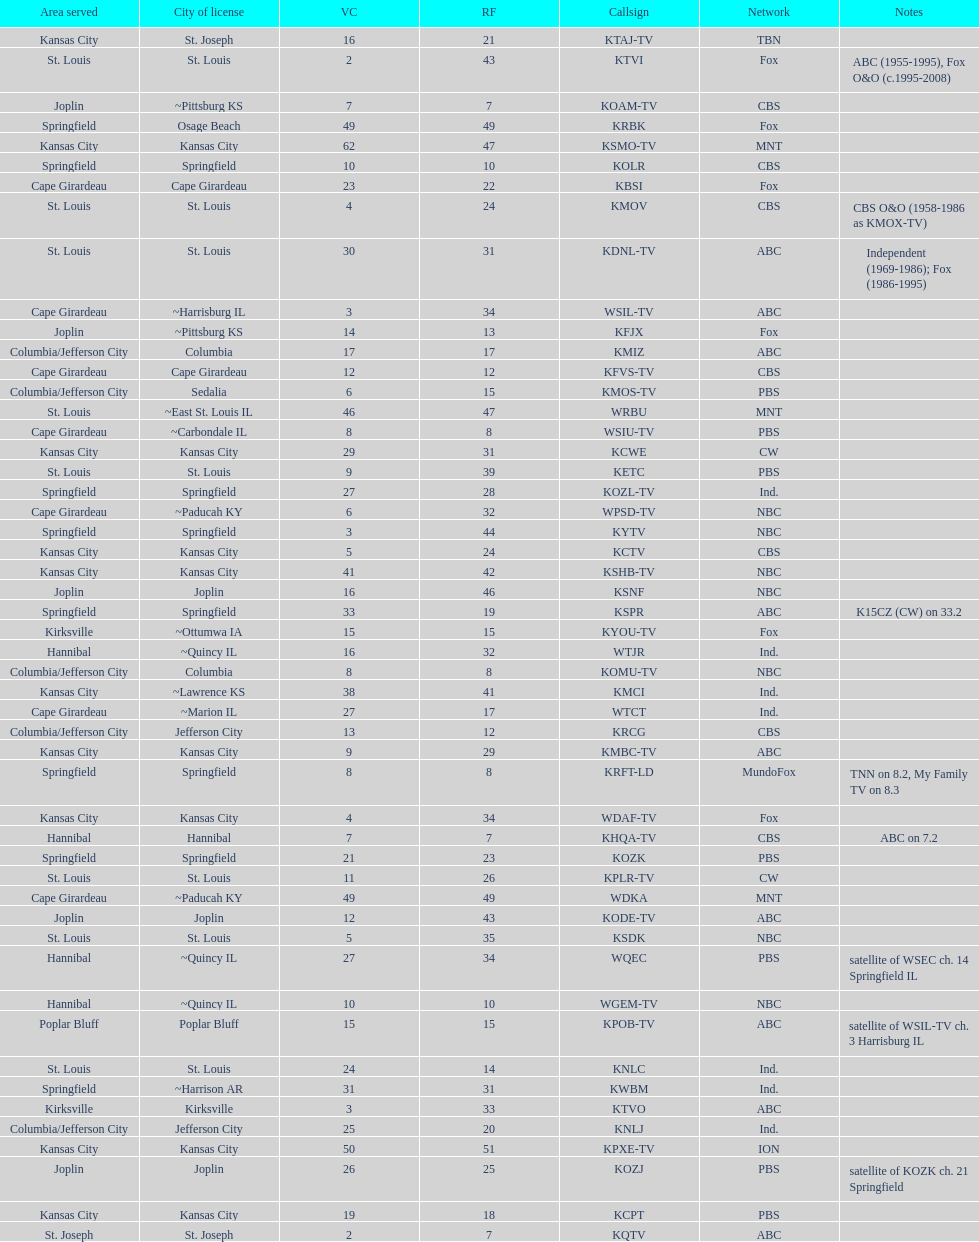What is the total number of stations serving the the cape girardeau area? 7. 